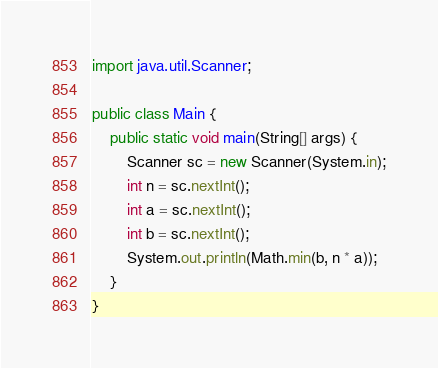Convert code to text. <code><loc_0><loc_0><loc_500><loc_500><_Java_>import java.util.Scanner;

public class Main {
	public static void main(String[] args) {
		Scanner sc = new Scanner(System.in);
		int n = sc.nextInt();
		int a = sc.nextInt();
		int b = sc.nextInt();
		System.out.println(Math.min(b, n * a));
	}
}
</code> 